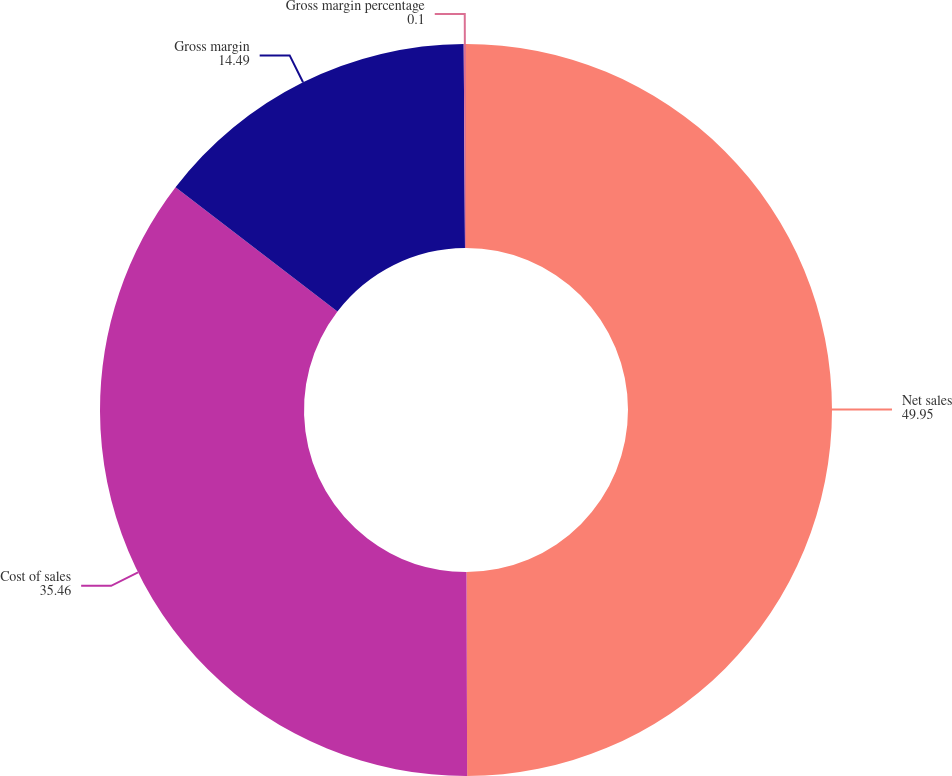Convert chart. <chart><loc_0><loc_0><loc_500><loc_500><pie_chart><fcel>Net sales<fcel>Cost of sales<fcel>Gross margin<fcel>Gross margin percentage<nl><fcel>49.95%<fcel>35.46%<fcel>14.49%<fcel>0.1%<nl></chart> 